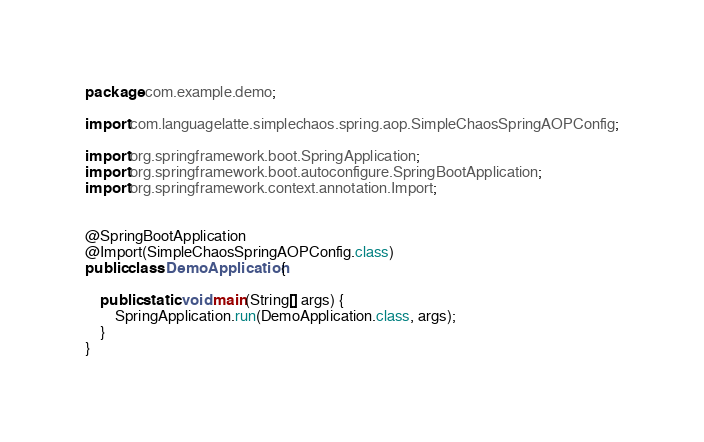<code> <loc_0><loc_0><loc_500><loc_500><_Java_>package com.example.demo;

import com.languagelatte.simplechaos.spring.aop.SimpleChaosSpringAOPConfig;

import org.springframework.boot.SpringApplication;
import org.springframework.boot.autoconfigure.SpringBootApplication;
import org.springframework.context.annotation.Import;


@SpringBootApplication
@Import(SimpleChaosSpringAOPConfig.class)
public class DemoApplication {

	public static void main(String[] args) {
		SpringApplication.run(DemoApplication.class, args);
	}
}
</code> 